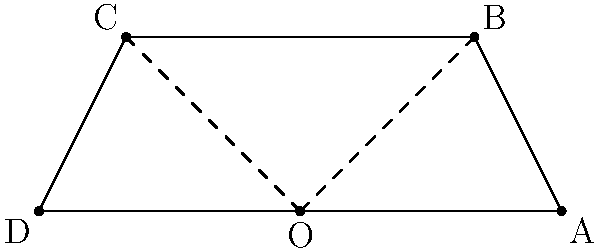A new tire design for a high-performance car has a contact patch represented by the quadrilateral ABCD in the coordinate plane. Point O is the origin (0,0), and the coordinates of the other points are A(3,0), B(2,2), C(-2,2), and D(-3,0). To optimize the tire's performance, you need to maximize the contact patch area. Calculate the area of the quadrilateral ABCD to determine the optimal contact patch size. To calculate the area of the quadrilateral ABCD, we can use the shoelace formula (also known as the surveyor's formula). The steps are as follows:

1) The shoelace formula for a quadrilateral with vertices $(x_1,y_1)$, $(x_2,y_2)$, $(x_3,y_3)$, and $(x_4,y_4)$ is:

   Area = $\frac{1}{2}|x_1y_2 + x_2y_3 + x_3y_4 + x_4y_1 - y_1x_2 - y_2x_3 - y_3x_4 - y_4x_1|$

2) Substitute the given coordinates:
   A(3,0), B(2,2), C(-2,2), D(-3,0)

3) Apply the formula:

   Area = $\frac{1}{2}|(3 \cdot 2 + 2 \cdot 2 + (-2) \cdot 0 + (-3) \cdot 0) - (0 \cdot 2 + 2 \cdot (-2) + 2 \cdot (-3) + 0 \cdot 3)|$

4) Simplify:
   Area = $\frac{1}{2}|(6 + 4 + 0 + 0) - (0 - 4 - 6 + 0)|$
   Area = $\frac{1}{2}|10 - (-10)|$
   Area = $\frac{1}{2}|10 + 10|$
   Area = $\frac{1}{2}|20|$
   Area = $\frac{1}{2} \cdot 20 = 10$

5) Therefore, the area of the quadrilateral ABCD is 10 square units.
Answer: 10 square units 